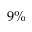<formula> <loc_0><loc_0><loc_500><loc_500>9 \%</formula> 